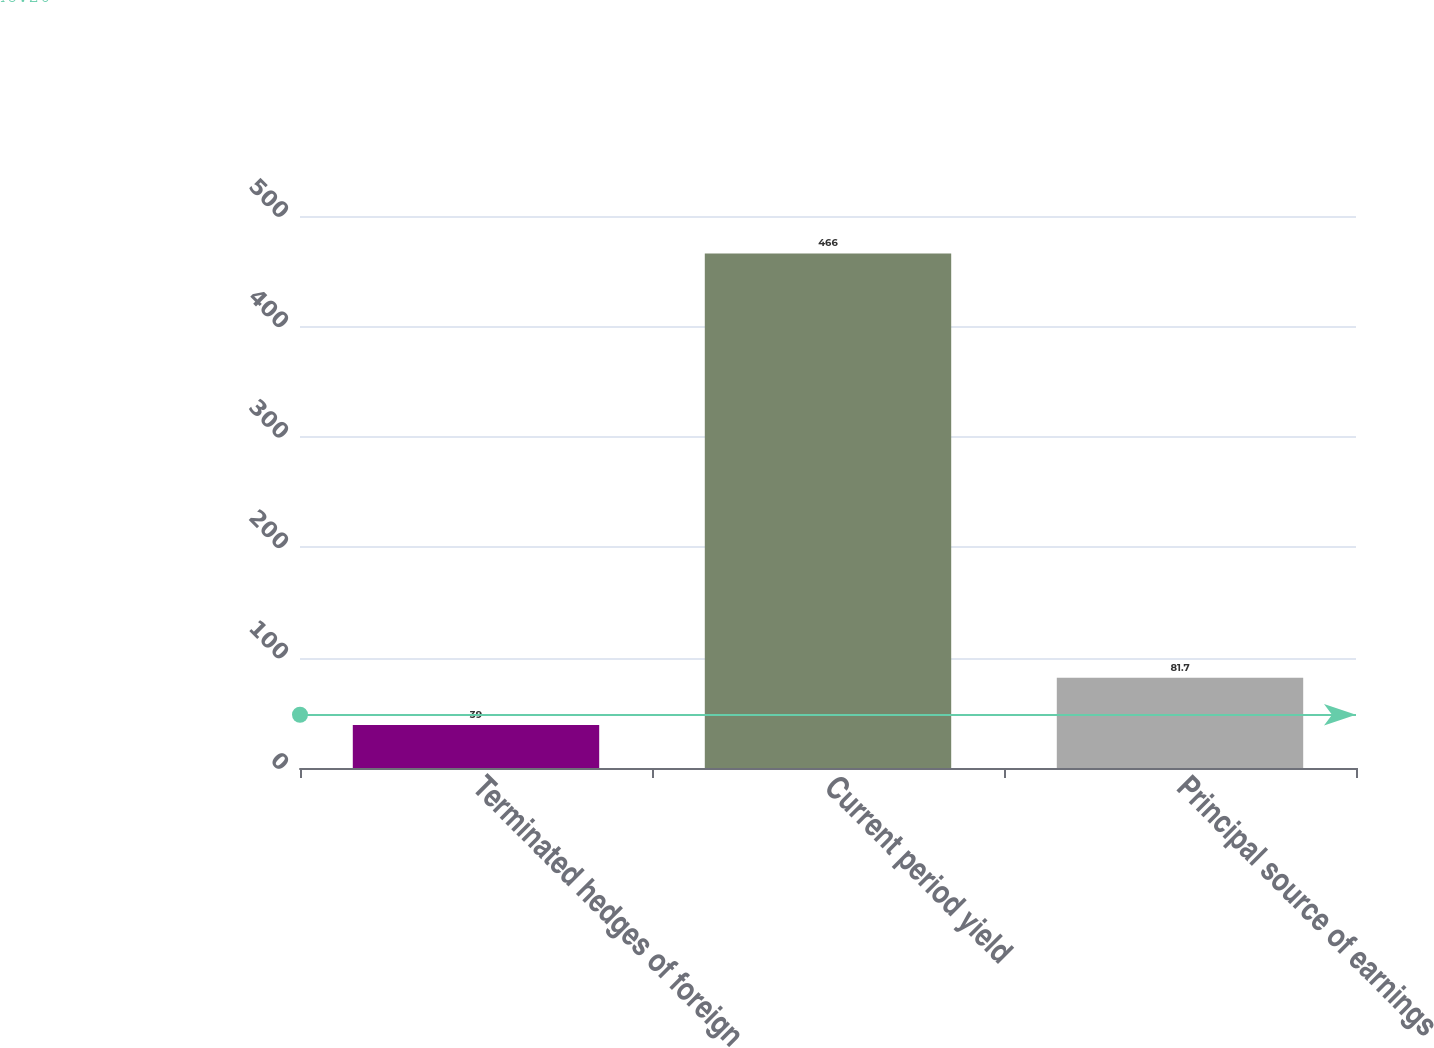<chart> <loc_0><loc_0><loc_500><loc_500><bar_chart><fcel>Terminated hedges of foreign<fcel>Current period yield<fcel>Principal source of earnings<nl><fcel>39<fcel>466<fcel>81.7<nl></chart> 